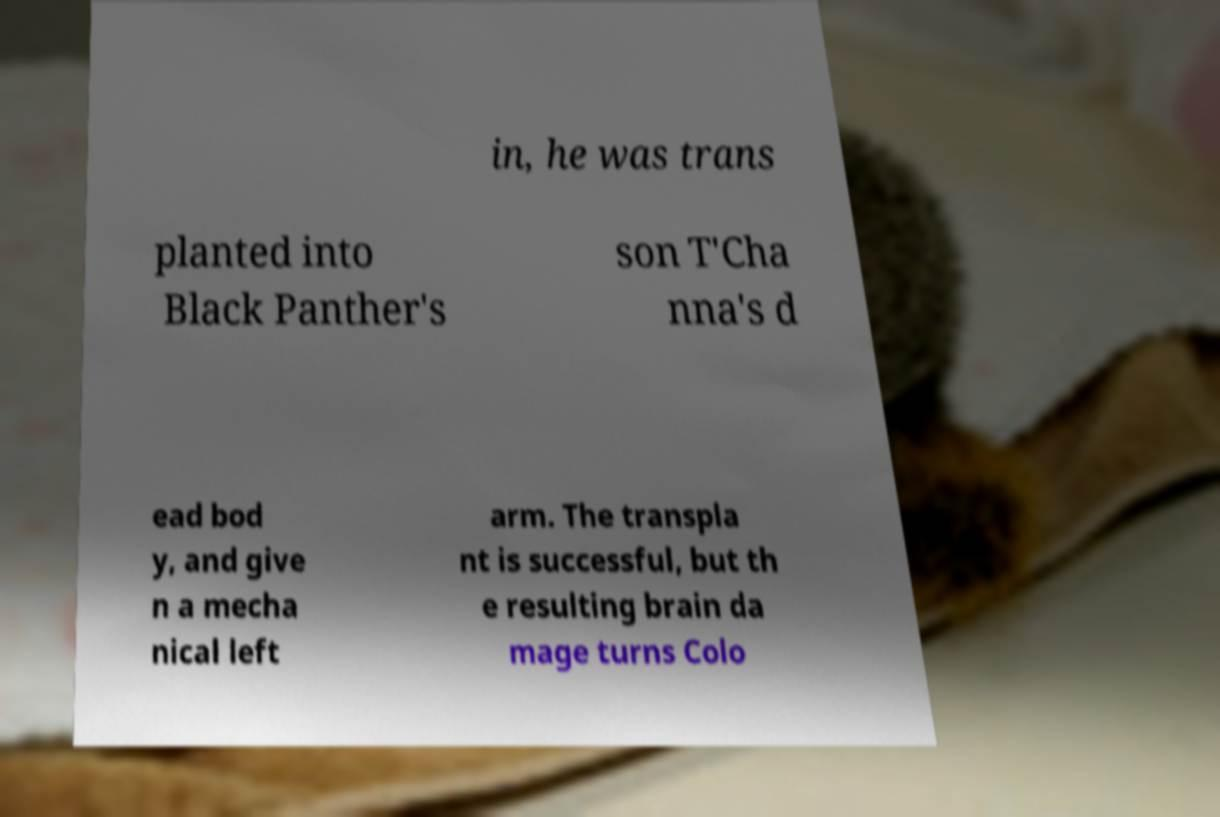There's text embedded in this image that I need extracted. Can you transcribe it verbatim? in, he was trans planted into Black Panther's son T'Cha nna's d ead bod y, and give n a mecha nical left arm. The transpla nt is successful, but th e resulting brain da mage turns Colo 